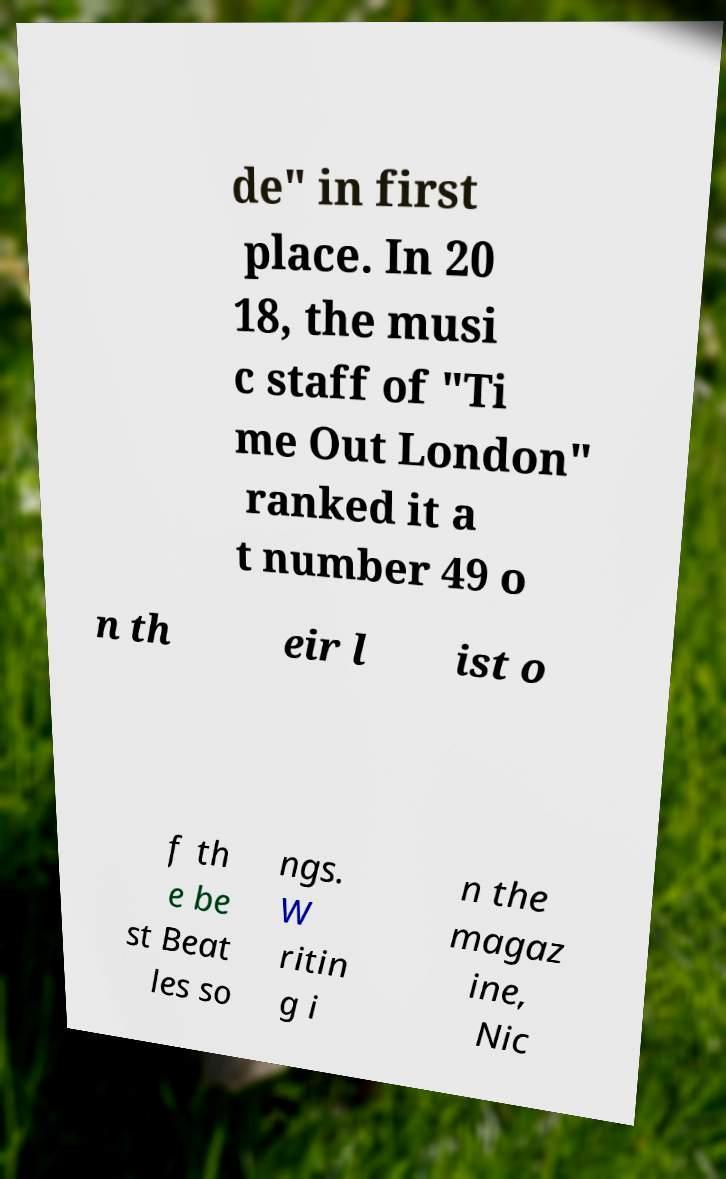Could you assist in decoding the text presented in this image and type it out clearly? de" in first place. In 20 18, the musi c staff of "Ti me Out London" ranked it a t number 49 o n th eir l ist o f th e be st Beat les so ngs. W ritin g i n the magaz ine, Nic 